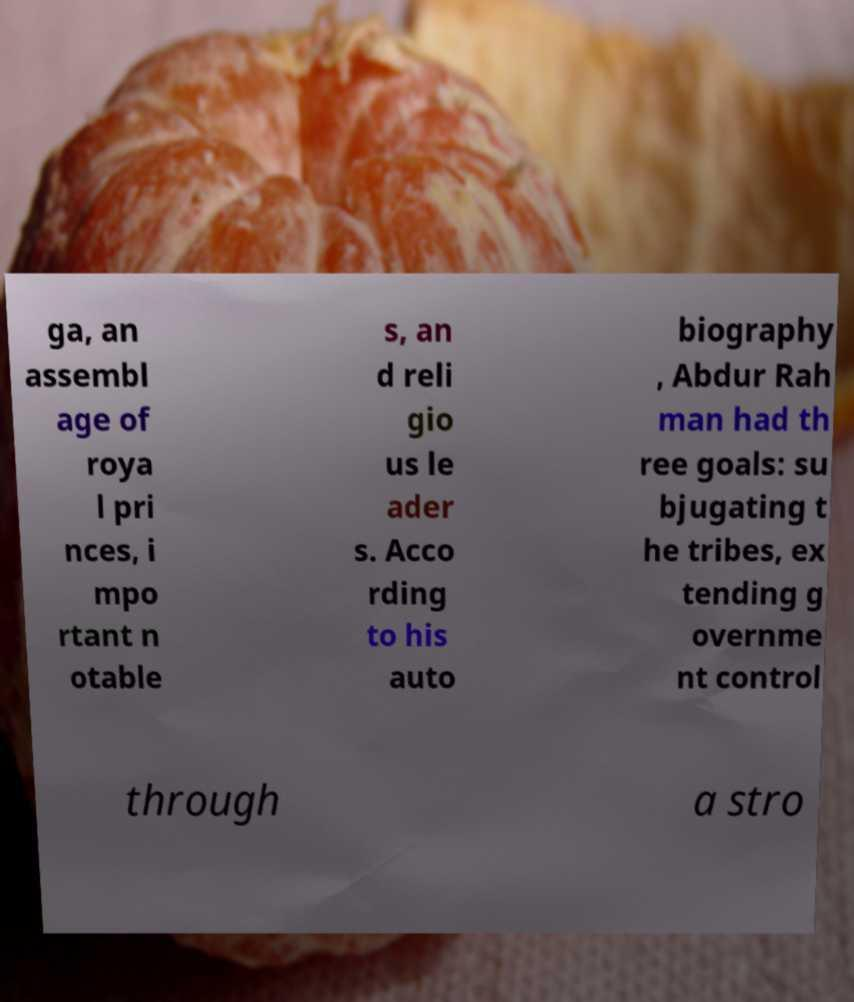I need the written content from this picture converted into text. Can you do that? ga, an assembl age of roya l pri nces, i mpo rtant n otable s, an d reli gio us le ader s. Acco rding to his auto biography , Abdur Rah man had th ree goals: su bjugating t he tribes, ex tending g overnme nt control through a stro 